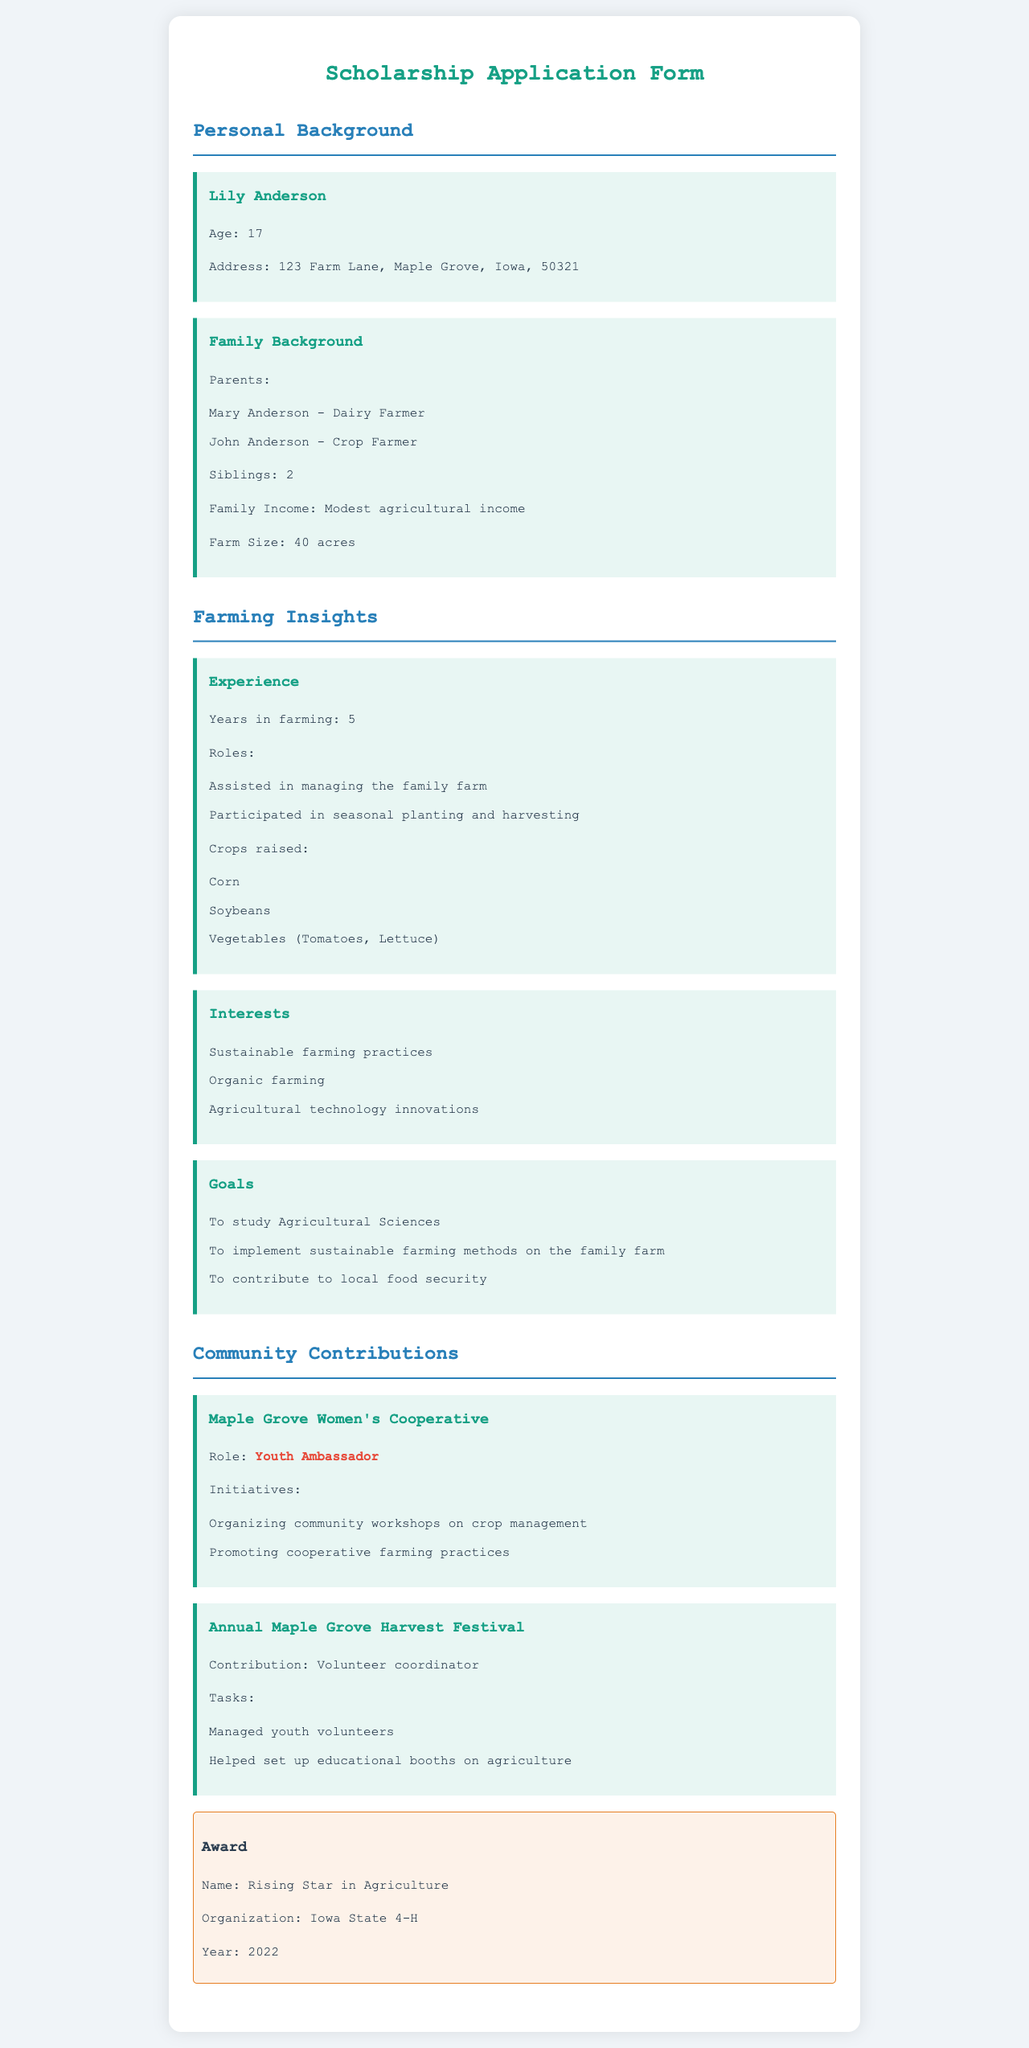What is the applicant's name? The name of the applicant is given in the personal background section of the document.
Answer: Lily Anderson How old is Lily Anderson? The age of Lily Anderson is stated in the personal background section.
Answer: 17 What is the family income mentioned? The family income is described in the family background section of the document.
Answer: Modest agricultural income How many acres does the family farm? The size of the family farm is specified in the family background section.
Answer: 40 acres What crops does Lily raise? The crops raised by Lily are listed in the farming insights section.
Answer: Corn, Soybeans, Vegetables (Tomatoes, Lettuce) What is Lily's role in the Maple Grove Women's Cooperative? The role of Lily is mentioned in the community contributions section.
Answer: Youth Ambassador What was Lily's contribution to the Annual Maple Grove Harvest Festival? Lily's contribution is specified in the community contributions section.
Answer: Volunteer coordinator What award did Lily receive and in what year? The award received by Lily and the year are mentioned in the community contributions section.
Answer: Rising Star in Agriculture, 2022 What are Lily's interests in farming? Lily's interests in farming are listed in the farming insights section.
Answer: Sustainable farming practices, Organic farming, Agricultural technology innovations 